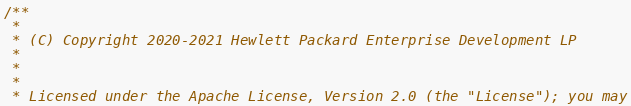<code> <loc_0><loc_0><loc_500><loc_500><_C_>/**
 *
 * (C) Copyright 2020-2021 Hewlett Packard Enterprise Development LP
 *
 *
 *
 * Licensed under the Apache License, Version 2.0 (the "License"); you may</code> 